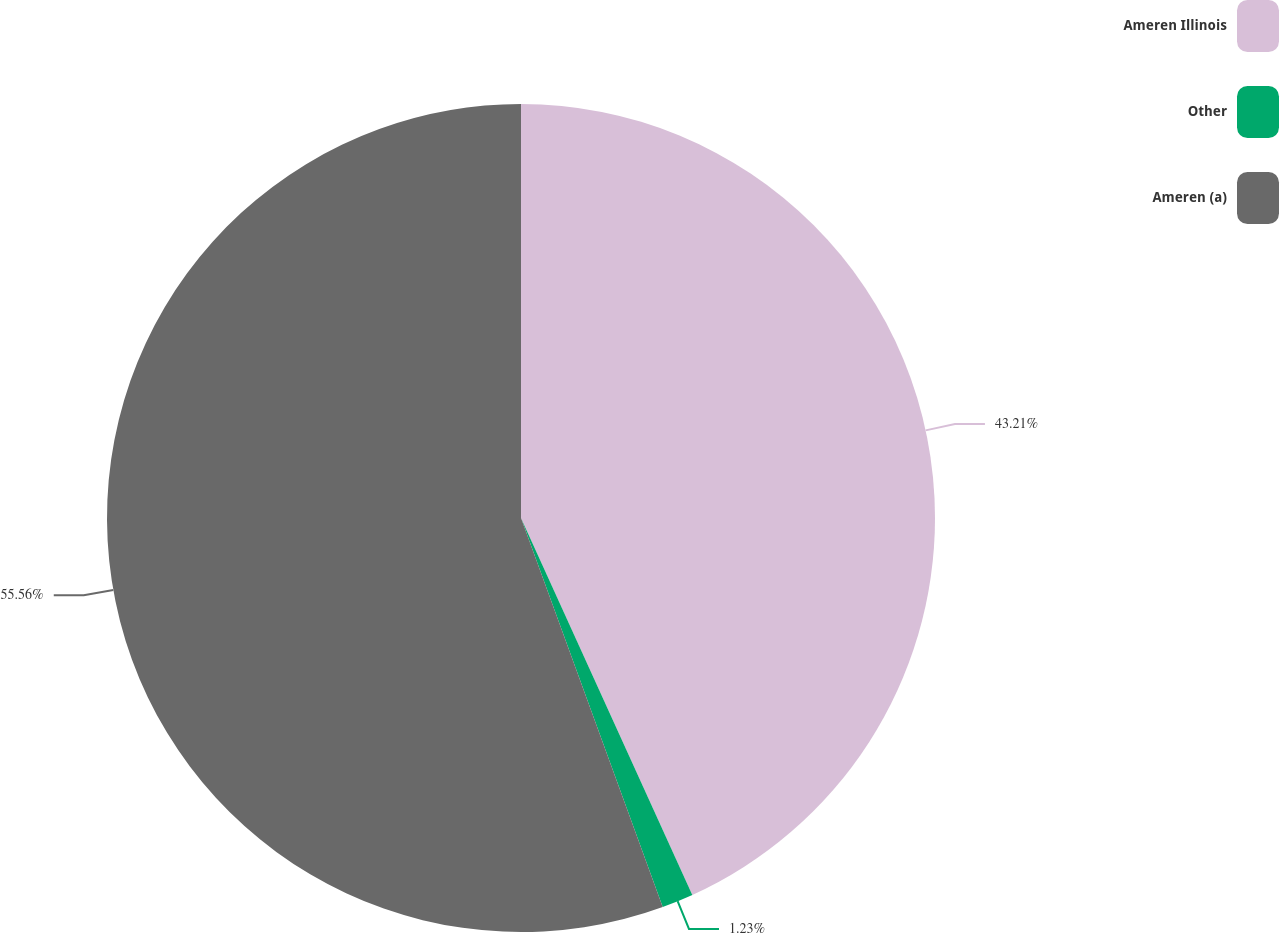Convert chart. <chart><loc_0><loc_0><loc_500><loc_500><pie_chart><fcel>Ameren Illinois<fcel>Other<fcel>Ameren (a)<nl><fcel>43.21%<fcel>1.23%<fcel>55.56%<nl></chart> 